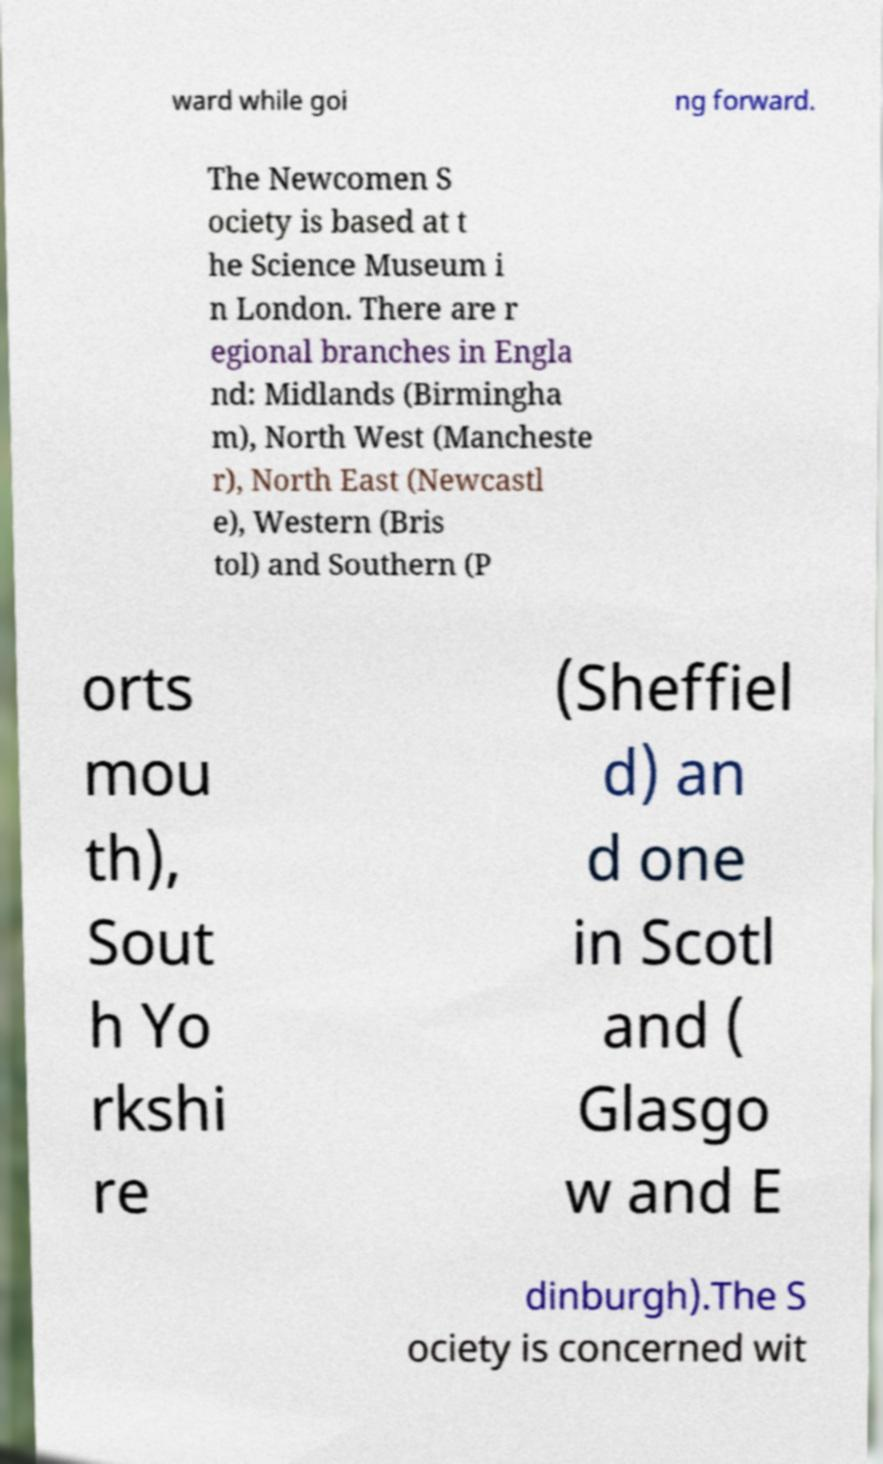Please read and relay the text visible in this image. What does it say? ward while goi ng forward. The Newcomen S ociety is based at t he Science Museum i n London. There are r egional branches in Engla nd: Midlands (Birmingha m), North West (Mancheste r), North East (Newcastl e), Western (Bris tol) and Southern (P orts mou th), Sout h Yo rkshi re (Sheffiel d) an d one in Scotl and ( Glasgo w and E dinburgh).The S ociety is concerned wit 